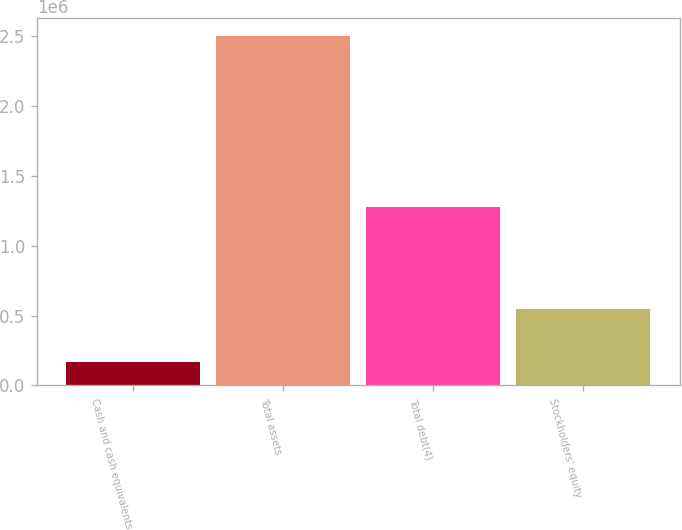Convert chart to OTSL. <chart><loc_0><loc_0><loc_500><loc_500><bar_chart><fcel>Cash and cash equivalents<fcel>Total assets<fcel>Total debt(4)<fcel>Stockholders' equity<nl><fcel>165801<fcel>2.50445e+06<fcel>1.27589e+06<fcel>547589<nl></chart> 